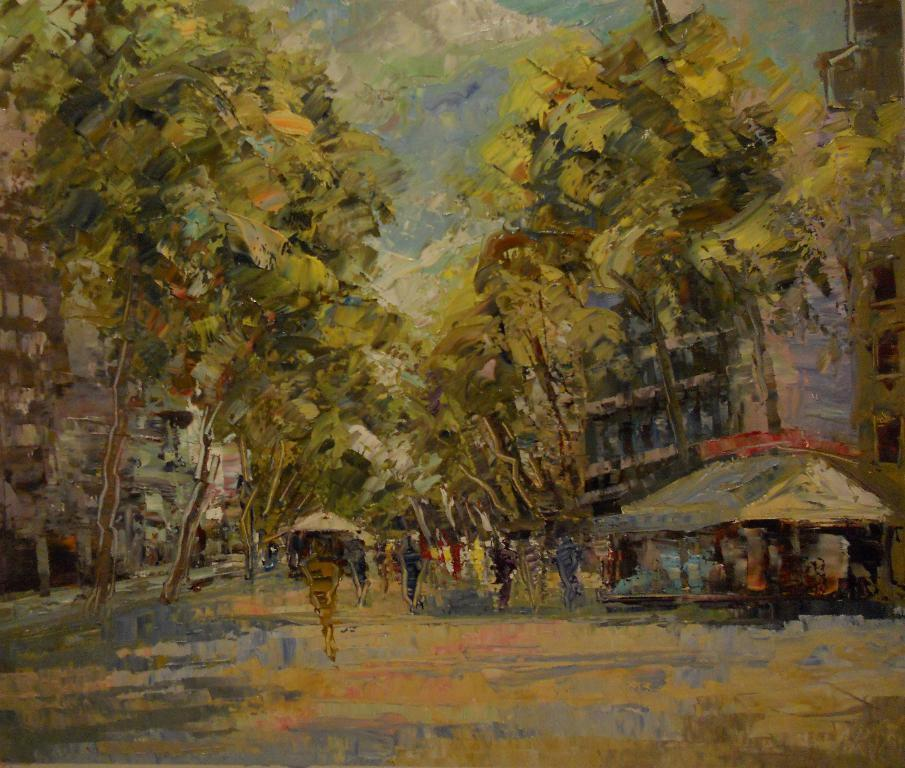What is the main subject of the painting in the image? The painting depicts the sky with clouds. What other elements are present in the painting? The painting includes trees, buildings, a shed, and persons on the road. What type of mine is visible in the painting? There is no mine present in the painting; it features a sky with clouds, trees, buildings, a shed, and persons on the road. 